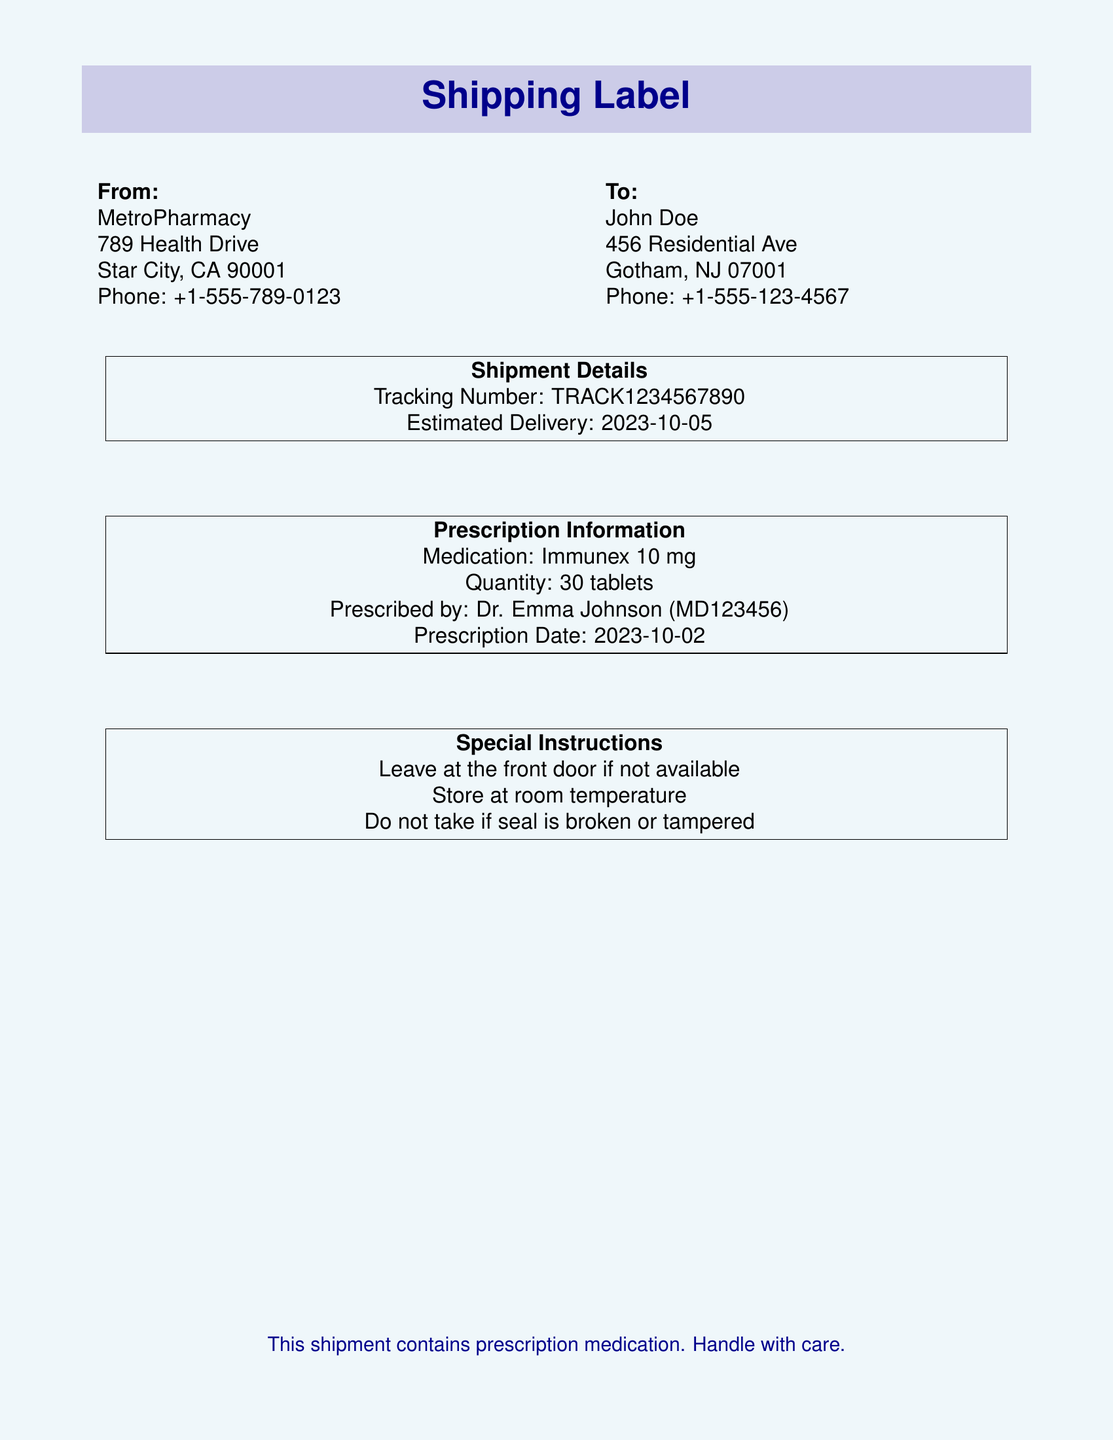What is the name of the pharmacy? The pharmacy's name is located at the beginning of the document under "From".
Answer: MetroPharmacy What is the medication prescribed? The medication is listed under "Prescription Information".
Answer: Immunex 10 mg What is the tracking number? The tracking number is mentioned in the "Shipment Details" section.
Answer: TRACK1234567890 Who is the prescribing doctor? The doctor's name is provided in the "Prescription Information" section.
Answer: Dr. Emma Johnson What is the prescription date? The prescription date can be found in the "Prescription Information" section.
Answer: 2023-10-02 What quantity of medication is shipped? The quantity is specified under "Prescription Information".
Answer: 30 tablets When is the estimated delivery date? The estimated delivery date is listed in the "Shipment Details" section.
Answer: 2023-10-05 What special instruction is provided regarding the medication? Special instructions are provided in the "Special Instructions" section.
Answer: Leave at the front door if not available What should be checked before taking the medication? The document lists safety checks in the "Special Instructions".
Answer: Do not take if seal is broken or tampered 